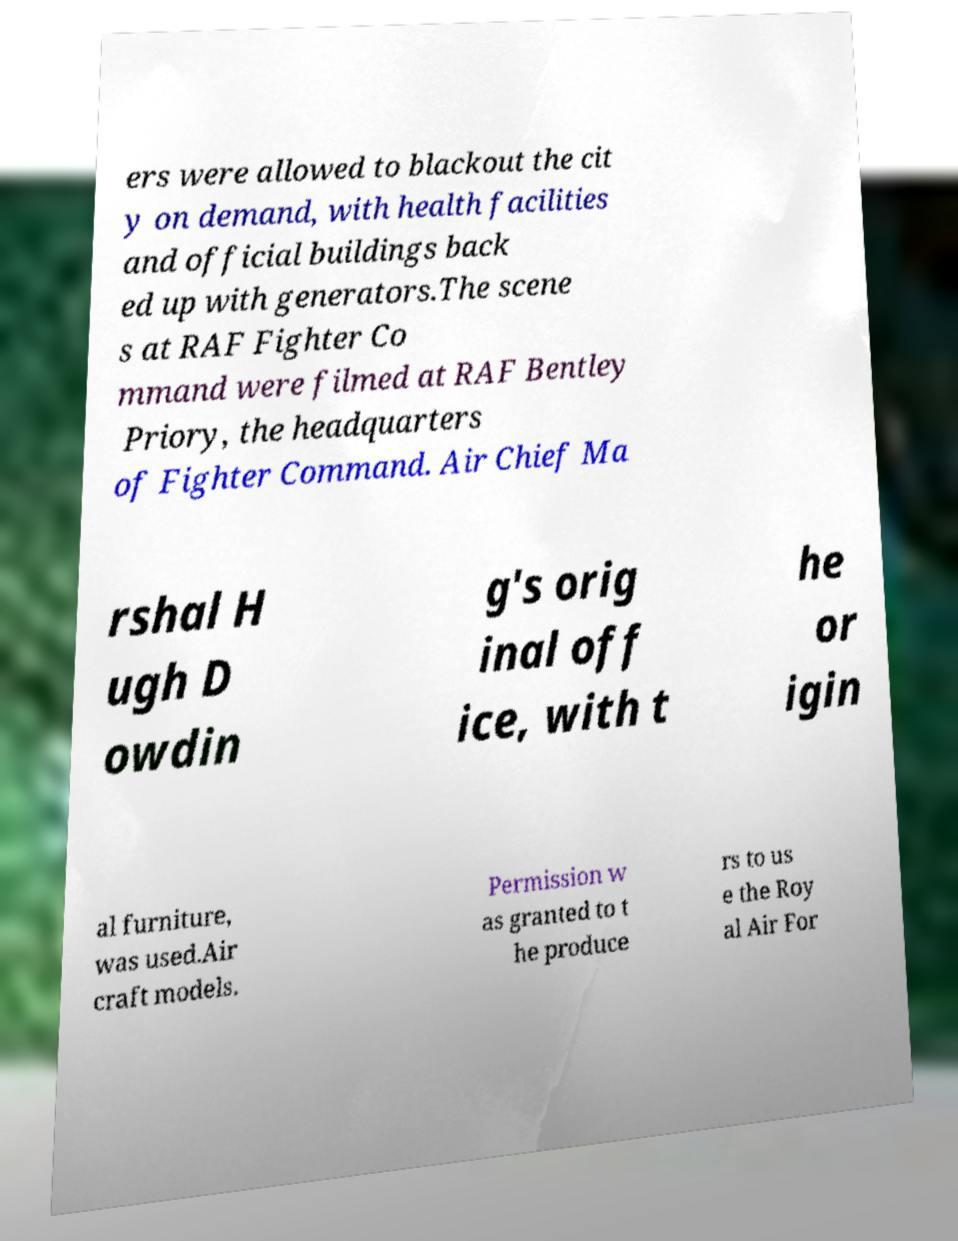For documentation purposes, I need the text within this image transcribed. Could you provide that? ers were allowed to blackout the cit y on demand, with health facilities and official buildings back ed up with generators.The scene s at RAF Fighter Co mmand were filmed at RAF Bentley Priory, the headquarters of Fighter Command. Air Chief Ma rshal H ugh D owdin g's orig inal off ice, with t he or igin al furniture, was used.Air craft models. Permission w as granted to t he produce rs to us e the Roy al Air For 